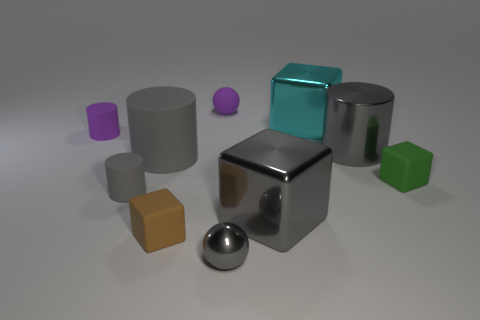What number of other things are the same color as the small metallic object?
Make the answer very short. 4. There is a small sphere in front of the tiny matte cube to the left of the green matte cube; what is its material?
Your answer should be very brief. Metal. Are there any gray matte objects?
Your answer should be compact. Yes. There is a metallic cube that is in front of the small rubber cube that is to the right of the tiny gray metal ball; what size is it?
Offer a terse response. Large. Are there more small brown rubber blocks behind the green thing than tiny purple matte objects that are in front of the tiny purple matte ball?
Make the answer very short. No. What number of cubes are tiny blue matte objects or green things?
Give a very brief answer. 1. Do the tiny purple object left of the tiny brown matte block and the large gray rubber thing have the same shape?
Provide a short and direct response. Yes. What is the color of the large shiny cylinder?
Your answer should be very brief. Gray. What is the color of the other metallic object that is the same shape as the cyan metallic thing?
Offer a very short reply. Gray. What number of purple things have the same shape as the small brown thing?
Your response must be concise. 0. 